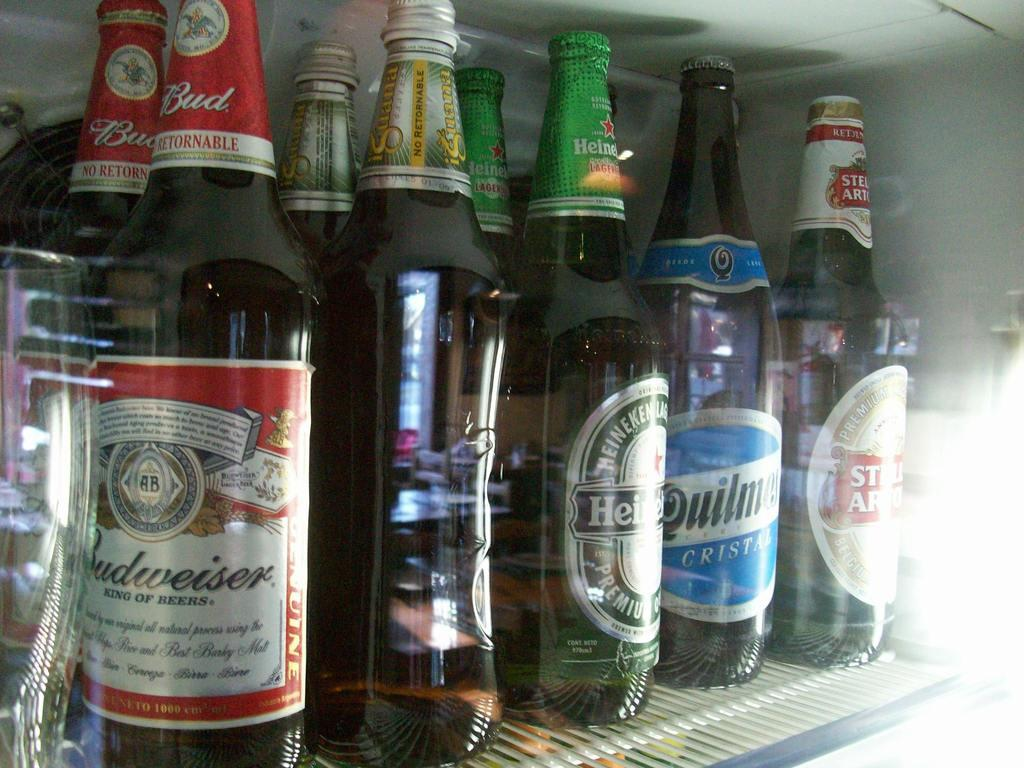Provide a one-sentence caption for the provided image. Bottle of beer including Budweiser and Stella Artois. 